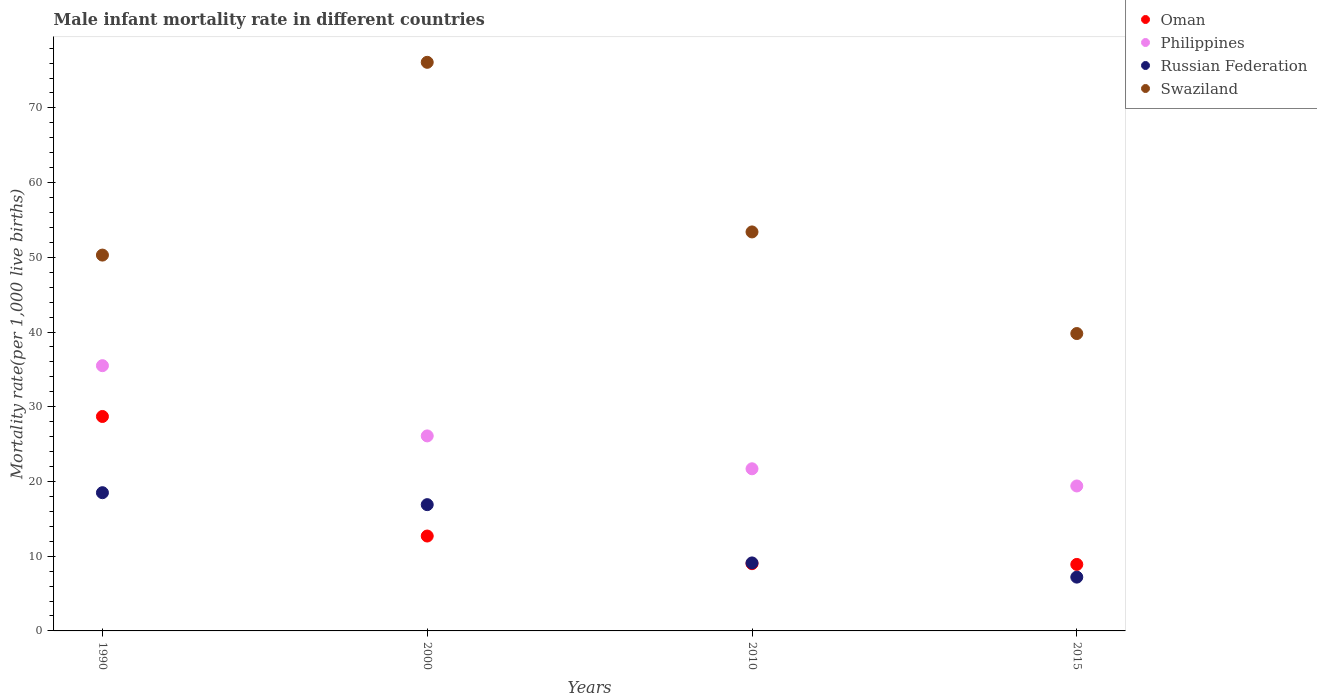In which year was the male infant mortality rate in Philippines maximum?
Ensure brevity in your answer.  1990. In which year was the male infant mortality rate in Philippines minimum?
Ensure brevity in your answer.  2015. What is the total male infant mortality rate in Swaziland in the graph?
Your answer should be compact. 219.6. What is the difference between the male infant mortality rate in Russian Federation in 2000 and that in 2015?
Ensure brevity in your answer.  9.7. What is the difference between the male infant mortality rate in Philippines in 1990 and the male infant mortality rate in Russian Federation in 2010?
Ensure brevity in your answer.  26.4. What is the average male infant mortality rate in Russian Federation per year?
Give a very brief answer. 12.93. In the year 2010, what is the difference between the male infant mortality rate in Swaziland and male infant mortality rate in Philippines?
Provide a short and direct response. 31.7. In how many years, is the male infant mortality rate in Oman greater than 30?
Provide a short and direct response. 0. What is the ratio of the male infant mortality rate in Swaziland in 2000 to that in 2010?
Ensure brevity in your answer.  1.43. What is the difference between the highest and the second highest male infant mortality rate in Swaziland?
Offer a very short reply. 22.7. What is the difference between the highest and the lowest male infant mortality rate in Oman?
Offer a terse response. 19.8. In how many years, is the male infant mortality rate in Philippines greater than the average male infant mortality rate in Philippines taken over all years?
Offer a very short reply. 2. Does the male infant mortality rate in Swaziland monotonically increase over the years?
Keep it short and to the point. No. Is the male infant mortality rate in Swaziland strictly greater than the male infant mortality rate in Russian Federation over the years?
Offer a terse response. Yes. How many dotlines are there?
Your answer should be compact. 4. How many years are there in the graph?
Ensure brevity in your answer.  4. What is the difference between two consecutive major ticks on the Y-axis?
Keep it short and to the point. 10. Does the graph contain any zero values?
Offer a terse response. No. Does the graph contain grids?
Offer a terse response. No. How many legend labels are there?
Provide a short and direct response. 4. What is the title of the graph?
Give a very brief answer. Male infant mortality rate in different countries. Does "Timor-Leste" appear as one of the legend labels in the graph?
Give a very brief answer. No. What is the label or title of the X-axis?
Your answer should be compact. Years. What is the label or title of the Y-axis?
Provide a succinct answer. Mortality rate(per 1,0 live births). What is the Mortality rate(per 1,000 live births) in Oman in 1990?
Offer a very short reply. 28.7. What is the Mortality rate(per 1,000 live births) in Philippines in 1990?
Your answer should be compact. 35.5. What is the Mortality rate(per 1,000 live births) of Swaziland in 1990?
Ensure brevity in your answer.  50.3. What is the Mortality rate(per 1,000 live births) in Oman in 2000?
Keep it short and to the point. 12.7. What is the Mortality rate(per 1,000 live births) of Philippines in 2000?
Give a very brief answer. 26.1. What is the Mortality rate(per 1,000 live births) of Russian Federation in 2000?
Ensure brevity in your answer.  16.9. What is the Mortality rate(per 1,000 live births) of Swaziland in 2000?
Your answer should be very brief. 76.1. What is the Mortality rate(per 1,000 live births) in Oman in 2010?
Your response must be concise. 9. What is the Mortality rate(per 1,000 live births) in Philippines in 2010?
Provide a short and direct response. 21.7. What is the Mortality rate(per 1,000 live births) in Swaziland in 2010?
Offer a terse response. 53.4. What is the Mortality rate(per 1,000 live births) in Philippines in 2015?
Provide a short and direct response. 19.4. What is the Mortality rate(per 1,000 live births) in Swaziland in 2015?
Your answer should be compact. 39.8. Across all years, what is the maximum Mortality rate(per 1,000 live births) of Oman?
Offer a terse response. 28.7. Across all years, what is the maximum Mortality rate(per 1,000 live births) in Philippines?
Give a very brief answer. 35.5. Across all years, what is the maximum Mortality rate(per 1,000 live births) of Swaziland?
Ensure brevity in your answer.  76.1. Across all years, what is the minimum Mortality rate(per 1,000 live births) of Oman?
Keep it short and to the point. 8.9. Across all years, what is the minimum Mortality rate(per 1,000 live births) of Swaziland?
Provide a succinct answer. 39.8. What is the total Mortality rate(per 1,000 live births) in Oman in the graph?
Your answer should be compact. 59.3. What is the total Mortality rate(per 1,000 live births) of Philippines in the graph?
Offer a terse response. 102.7. What is the total Mortality rate(per 1,000 live births) in Russian Federation in the graph?
Ensure brevity in your answer.  51.7. What is the total Mortality rate(per 1,000 live births) in Swaziland in the graph?
Give a very brief answer. 219.6. What is the difference between the Mortality rate(per 1,000 live births) of Philippines in 1990 and that in 2000?
Provide a short and direct response. 9.4. What is the difference between the Mortality rate(per 1,000 live births) of Russian Federation in 1990 and that in 2000?
Give a very brief answer. 1.6. What is the difference between the Mortality rate(per 1,000 live births) in Swaziland in 1990 and that in 2000?
Provide a succinct answer. -25.8. What is the difference between the Mortality rate(per 1,000 live births) in Philippines in 1990 and that in 2010?
Provide a short and direct response. 13.8. What is the difference between the Mortality rate(per 1,000 live births) of Russian Federation in 1990 and that in 2010?
Provide a succinct answer. 9.4. What is the difference between the Mortality rate(per 1,000 live births) of Oman in 1990 and that in 2015?
Your response must be concise. 19.8. What is the difference between the Mortality rate(per 1,000 live births) in Philippines in 1990 and that in 2015?
Ensure brevity in your answer.  16.1. What is the difference between the Mortality rate(per 1,000 live births) of Russian Federation in 1990 and that in 2015?
Keep it short and to the point. 11.3. What is the difference between the Mortality rate(per 1,000 live births) in Philippines in 2000 and that in 2010?
Offer a very short reply. 4.4. What is the difference between the Mortality rate(per 1,000 live births) in Russian Federation in 2000 and that in 2010?
Offer a very short reply. 7.8. What is the difference between the Mortality rate(per 1,000 live births) of Swaziland in 2000 and that in 2010?
Offer a terse response. 22.7. What is the difference between the Mortality rate(per 1,000 live births) of Oman in 2000 and that in 2015?
Give a very brief answer. 3.8. What is the difference between the Mortality rate(per 1,000 live births) in Philippines in 2000 and that in 2015?
Offer a very short reply. 6.7. What is the difference between the Mortality rate(per 1,000 live births) in Swaziland in 2000 and that in 2015?
Your answer should be very brief. 36.3. What is the difference between the Mortality rate(per 1,000 live births) in Philippines in 2010 and that in 2015?
Offer a very short reply. 2.3. What is the difference between the Mortality rate(per 1,000 live births) of Swaziland in 2010 and that in 2015?
Give a very brief answer. 13.6. What is the difference between the Mortality rate(per 1,000 live births) in Oman in 1990 and the Mortality rate(per 1,000 live births) in Philippines in 2000?
Provide a succinct answer. 2.6. What is the difference between the Mortality rate(per 1,000 live births) of Oman in 1990 and the Mortality rate(per 1,000 live births) of Swaziland in 2000?
Keep it short and to the point. -47.4. What is the difference between the Mortality rate(per 1,000 live births) of Philippines in 1990 and the Mortality rate(per 1,000 live births) of Swaziland in 2000?
Give a very brief answer. -40.6. What is the difference between the Mortality rate(per 1,000 live births) of Russian Federation in 1990 and the Mortality rate(per 1,000 live births) of Swaziland in 2000?
Your answer should be very brief. -57.6. What is the difference between the Mortality rate(per 1,000 live births) of Oman in 1990 and the Mortality rate(per 1,000 live births) of Philippines in 2010?
Make the answer very short. 7. What is the difference between the Mortality rate(per 1,000 live births) of Oman in 1990 and the Mortality rate(per 1,000 live births) of Russian Federation in 2010?
Provide a succinct answer. 19.6. What is the difference between the Mortality rate(per 1,000 live births) of Oman in 1990 and the Mortality rate(per 1,000 live births) of Swaziland in 2010?
Keep it short and to the point. -24.7. What is the difference between the Mortality rate(per 1,000 live births) in Philippines in 1990 and the Mortality rate(per 1,000 live births) in Russian Federation in 2010?
Give a very brief answer. 26.4. What is the difference between the Mortality rate(per 1,000 live births) in Philippines in 1990 and the Mortality rate(per 1,000 live births) in Swaziland in 2010?
Ensure brevity in your answer.  -17.9. What is the difference between the Mortality rate(per 1,000 live births) of Russian Federation in 1990 and the Mortality rate(per 1,000 live births) of Swaziland in 2010?
Offer a very short reply. -34.9. What is the difference between the Mortality rate(per 1,000 live births) in Philippines in 1990 and the Mortality rate(per 1,000 live births) in Russian Federation in 2015?
Ensure brevity in your answer.  28.3. What is the difference between the Mortality rate(per 1,000 live births) in Russian Federation in 1990 and the Mortality rate(per 1,000 live births) in Swaziland in 2015?
Offer a very short reply. -21.3. What is the difference between the Mortality rate(per 1,000 live births) in Oman in 2000 and the Mortality rate(per 1,000 live births) in Swaziland in 2010?
Offer a very short reply. -40.7. What is the difference between the Mortality rate(per 1,000 live births) in Philippines in 2000 and the Mortality rate(per 1,000 live births) in Russian Federation in 2010?
Provide a succinct answer. 17. What is the difference between the Mortality rate(per 1,000 live births) in Philippines in 2000 and the Mortality rate(per 1,000 live births) in Swaziland in 2010?
Offer a very short reply. -27.3. What is the difference between the Mortality rate(per 1,000 live births) of Russian Federation in 2000 and the Mortality rate(per 1,000 live births) of Swaziland in 2010?
Your answer should be compact. -36.5. What is the difference between the Mortality rate(per 1,000 live births) in Oman in 2000 and the Mortality rate(per 1,000 live births) in Philippines in 2015?
Offer a terse response. -6.7. What is the difference between the Mortality rate(per 1,000 live births) in Oman in 2000 and the Mortality rate(per 1,000 live births) in Russian Federation in 2015?
Offer a very short reply. 5.5. What is the difference between the Mortality rate(per 1,000 live births) in Oman in 2000 and the Mortality rate(per 1,000 live births) in Swaziland in 2015?
Give a very brief answer. -27.1. What is the difference between the Mortality rate(per 1,000 live births) in Philippines in 2000 and the Mortality rate(per 1,000 live births) in Russian Federation in 2015?
Provide a short and direct response. 18.9. What is the difference between the Mortality rate(per 1,000 live births) in Philippines in 2000 and the Mortality rate(per 1,000 live births) in Swaziland in 2015?
Ensure brevity in your answer.  -13.7. What is the difference between the Mortality rate(per 1,000 live births) in Russian Federation in 2000 and the Mortality rate(per 1,000 live births) in Swaziland in 2015?
Offer a very short reply. -22.9. What is the difference between the Mortality rate(per 1,000 live births) in Oman in 2010 and the Mortality rate(per 1,000 live births) in Russian Federation in 2015?
Ensure brevity in your answer.  1.8. What is the difference between the Mortality rate(per 1,000 live births) of Oman in 2010 and the Mortality rate(per 1,000 live births) of Swaziland in 2015?
Ensure brevity in your answer.  -30.8. What is the difference between the Mortality rate(per 1,000 live births) in Philippines in 2010 and the Mortality rate(per 1,000 live births) in Russian Federation in 2015?
Your answer should be compact. 14.5. What is the difference between the Mortality rate(per 1,000 live births) in Philippines in 2010 and the Mortality rate(per 1,000 live births) in Swaziland in 2015?
Offer a very short reply. -18.1. What is the difference between the Mortality rate(per 1,000 live births) of Russian Federation in 2010 and the Mortality rate(per 1,000 live births) of Swaziland in 2015?
Provide a succinct answer. -30.7. What is the average Mortality rate(per 1,000 live births) in Oman per year?
Your answer should be compact. 14.82. What is the average Mortality rate(per 1,000 live births) of Philippines per year?
Keep it short and to the point. 25.68. What is the average Mortality rate(per 1,000 live births) in Russian Federation per year?
Provide a succinct answer. 12.93. What is the average Mortality rate(per 1,000 live births) of Swaziland per year?
Your answer should be very brief. 54.9. In the year 1990, what is the difference between the Mortality rate(per 1,000 live births) of Oman and Mortality rate(per 1,000 live births) of Philippines?
Make the answer very short. -6.8. In the year 1990, what is the difference between the Mortality rate(per 1,000 live births) in Oman and Mortality rate(per 1,000 live births) in Russian Federation?
Keep it short and to the point. 10.2. In the year 1990, what is the difference between the Mortality rate(per 1,000 live births) of Oman and Mortality rate(per 1,000 live births) of Swaziland?
Keep it short and to the point. -21.6. In the year 1990, what is the difference between the Mortality rate(per 1,000 live births) in Philippines and Mortality rate(per 1,000 live births) in Russian Federation?
Offer a very short reply. 17. In the year 1990, what is the difference between the Mortality rate(per 1,000 live births) of Philippines and Mortality rate(per 1,000 live births) of Swaziland?
Offer a terse response. -14.8. In the year 1990, what is the difference between the Mortality rate(per 1,000 live births) in Russian Federation and Mortality rate(per 1,000 live births) in Swaziland?
Your answer should be very brief. -31.8. In the year 2000, what is the difference between the Mortality rate(per 1,000 live births) in Oman and Mortality rate(per 1,000 live births) in Russian Federation?
Keep it short and to the point. -4.2. In the year 2000, what is the difference between the Mortality rate(per 1,000 live births) in Oman and Mortality rate(per 1,000 live births) in Swaziland?
Provide a short and direct response. -63.4. In the year 2000, what is the difference between the Mortality rate(per 1,000 live births) of Philippines and Mortality rate(per 1,000 live births) of Swaziland?
Offer a terse response. -50. In the year 2000, what is the difference between the Mortality rate(per 1,000 live births) of Russian Federation and Mortality rate(per 1,000 live births) of Swaziland?
Provide a succinct answer. -59.2. In the year 2010, what is the difference between the Mortality rate(per 1,000 live births) of Oman and Mortality rate(per 1,000 live births) of Philippines?
Keep it short and to the point. -12.7. In the year 2010, what is the difference between the Mortality rate(per 1,000 live births) of Oman and Mortality rate(per 1,000 live births) of Russian Federation?
Your response must be concise. -0.1. In the year 2010, what is the difference between the Mortality rate(per 1,000 live births) in Oman and Mortality rate(per 1,000 live births) in Swaziland?
Your answer should be very brief. -44.4. In the year 2010, what is the difference between the Mortality rate(per 1,000 live births) in Philippines and Mortality rate(per 1,000 live births) in Swaziland?
Offer a terse response. -31.7. In the year 2010, what is the difference between the Mortality rate(per 1,000 live births) in Russian Federation and Mortality rate(per 1,000 live births) in Swaziland?
Your response must be concise. -44.3. In the year 2015, what is the difference between the Mortality rate(per 1,000 live births) of Oman and Mortality rate(per 1,000 live births) of Russian Federation?
Provide a succinct answer. 1.7. In the year 2015, what is the difference between the Mortality rate(per 1,000 live births) of Oman and Mortality rate(per 1,000 live births) of Swaziland?
Ensure brevity in your answer.  -30.9. In the year 2015, what is the difference between the Mortality rate(per 1,000 live births) of Philippines and Mortality rate(per 1,000 live births) of Swaziland?
Provide a short and direct response. -20.4. In the year 2015, what is the difference between the Mortality rate(per 1,000 live births) in Russian Federation and Mortality rate(per 1,000 live births) in Swaziland?
Your response must be concise. -32.6. What is the ratio of the Mortality rate(per 1,000 live births) of Oman in 1990 to that in 2000?
Offer a very short reply. 2.26. What is the ratio of the Mortality rate(per 1,000 live births) in Philippines in 1990 to that in 2000?
Keep it short and to the point. 1.36. What is the ratio of the Mortality rate(per 1,000 live births) in Russian Federation in 1990 to that in 2000?
Your answer should be very brief. 1.09. What is the ratio of the Mortality rate(per 1,000 live births) in Swaziland in 1990 to that in 2000?
Your answer should be compact. 0.66. What is the ratio of the Mortality rate(per 1,000 live births) in Oman in 1990 to that in 2010?
Provide a succinct answer. 3.19. What is the ratio of the Mortality rate(per 1,000 live births) in Philippines in 1990 to that in 2010?
Provide a succinct answer. 1.64. What is the ratio of the Mortality rate(per 1,000 live births) in Russian Federation in 1990 to that in 2010?
Provide a short and direct response. 2.03. What is the ratio of the Mortality rate(per 1,000 live births) of Swaziland in 1990 to that in 2010?
Your response must be concise. 0.94. What is the ratio of the Mortality rate(per 1,000 live births) in Oman in 1990 to that in 2015?
Offer a very short reply. 3.22. What is the ratio of the Mortality rate(per 1,000 live births) in Philippines in 1990 to that in 2015?
Offer a very short reply. 1.83. What is the ratio of the Mortality rate(per 1,000 live births) of Russian Federation in 1990 to that in 2015?
Make the answer very short. 2.57. What is the ratio of the Mortality rate(per 1,000 live births) in Swaziland in 1990 to that in 2015?
Offer a very short reply. 1.26. What is the ratio of the Mortality rate(per 1,000 live births) of Oman in 2000 to that in 2010?
Your answer should be compact. 1.41. What is the ratio of the Mortality rate(per 1,000 live births) of Philippines in 2000 to that in 2010?
Make the answer very short. 1.2. What is the ratio of the Mortality rate(per 1,000 live births) of Russian Federation in 2000 to that in 2010?
Provide a short and direct response. 1.86. What is the ratio of the Mortality rate(per 1,000 live births) in Swaziland in 2000 to that in 2010?
Your answer should be compact. 1.43. What is the ratio of the Mortality rate(per 1,000 live births) in Oman in 2000 to that in 2015?
Ensure brevity in your answer.  1.43. What is the ratio of the Mortality rate(per 1,000 live births) of Philippines in 2000 to that in 2015?
Offer a terse response. 1.35. What is the ratio of the Mortality rate(per 1,000 live births) in Russian Federation in 2000 to that in 2015?
Offer a terse response. 2.35. What is the ratio of the Mortality rate(per 1,000 live births) of Swaziland in 2000 to that in 2015?
Give a very brief answer. 1.91. What is the ratio of the Mortality rate(per 1,000 live births) in Oman in 2010 to that in 2015?
Your answer should be compact. 1.01. What is the ratio of the Mortality rate(per 1,000 live births) in Philippines in 2010 to that in 2015?
Offer a terse response. 1.12. What is the ratio of the Mortality rate(per 1,000 live births) in Russian Federation in 2010 to that in 2015?
Give a very brief answer. 1.26. What is the ratio of the Mortality rate(per 1,000 live births) in Swaziland in 2010 to that in 2015?
Your answer should be compact. 1.34. What is the difference between the highest and the second highest Mortality rate(per 1,000 live births) in Oman?
Give a very brief answer. 16. What is the difference between the highest and the second highest Mortality rate(per 1,000 live births) of Russian Federation?
Keep it short and to the point. 1.6. What is the difference between the highest and the second highest Mortality rate(per 1,000 live births) in Swaziland?
Make the answer very short. 22.7. What is the difference between the highest and the lowest Mortality rate(per 1,000 live births) in Oman?
Your response must be concise. 19.8. What is the difference between the highest and the lowest Mortality rate(per 1,000 live births) in Swaziland?
Ensure brevity in your answer.  36.3. 